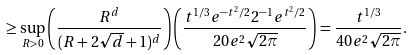Convert formula to latex. <formula><loc_0><loc_0><loc_500><loc_500>\geq \sup _ { R > 0 } \left ( \frac { R ^ { d } } { ( R + 2 \sqrt { d } + 1 ) ^ { d } } \right ) \left ( \frac { t ^ { 1 / 3 } e ^ { - t ^ { 2 } / 2 } 2 ^ { - 1 } e ^ { t ^ { 2 } / 2 } } { 2 0 e ^ { 2 } \sqrt { 2 \pi } } \right ) = \frac { t ^ { 1 / 3 } } { 4 0 e ^ { 2 } \sqrt { 2 \pi } } .</formula> 